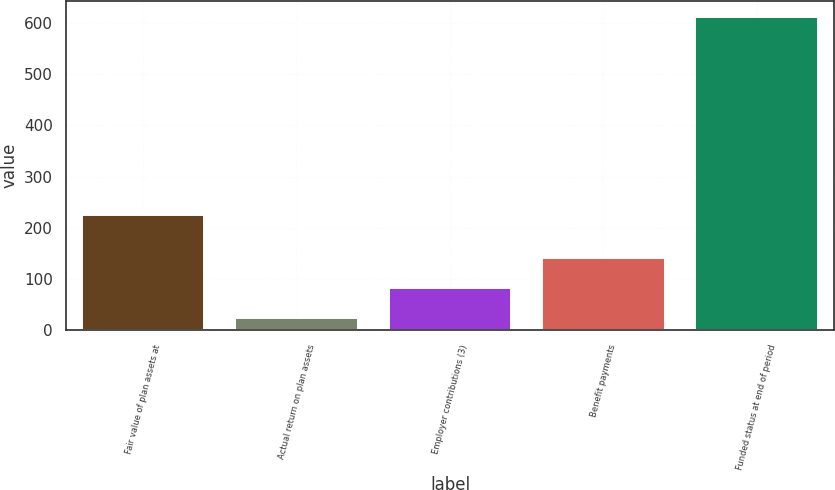Convert chart to OTSL. <chart><loc_0><loc_0><loc_500><loc_500><bar_chart><fcel>Fair value of plan assets at<fcel>Actual return on plan assets<fcel>Employer contributions (3)<fcel>Benefit payments<fcel>Funded status at end of period<nl><fcel>225<fcel>24<fcel>82.8<fcel>141.6<fcel>612<nl></chart> 